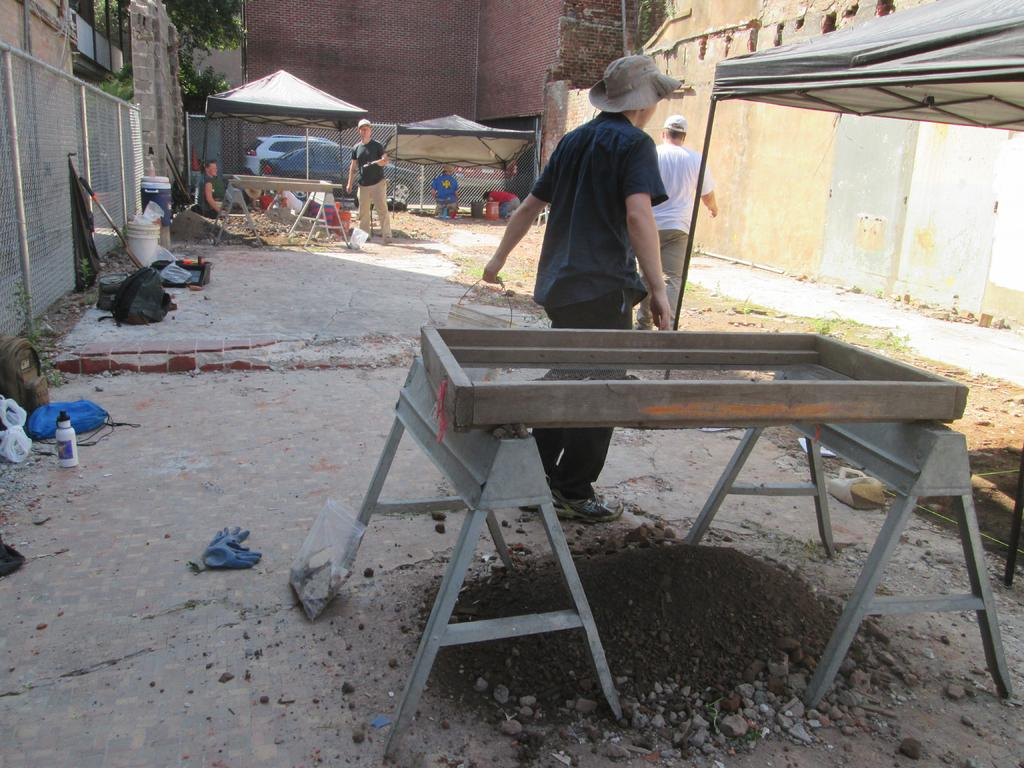What can be seen in the image? There is a person in the image. What is the person wearing? The person is wearing a blue shirt. What is the person holding in his hand? The person is carrying a bucket in his hand. What is in front of the person? There is an object in front of the person. What can be seen in the background of the image? There are people and buildings in the background of the image. How many flowers are being used as a cable in the image? There are no flowers or cables present in the image. 